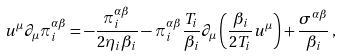Convert formula to latex. <formula><loc_0><loc_0><loc_500><loc_500>u ^ { \mu } \partial _ { \mu } \pi _ { i } ^ { \alpha \beta } = - \frac { \pi _ { i } ^ { \alpha \beta } } { 2 \eta _ { i } \beta _ { i } } - \pi _ { i } ^ { \alpha \beta } \frac { T _ { i } } { \beta _ { i } } \partial _ { \mu } \left ( \frac { \beta _ { i } } { 2 T _ { i } } u ^ { \mu } \right ) + \frac { \sigma ^ { \alpha \beta } } { \beta _ { i } } \, ,</formula> 